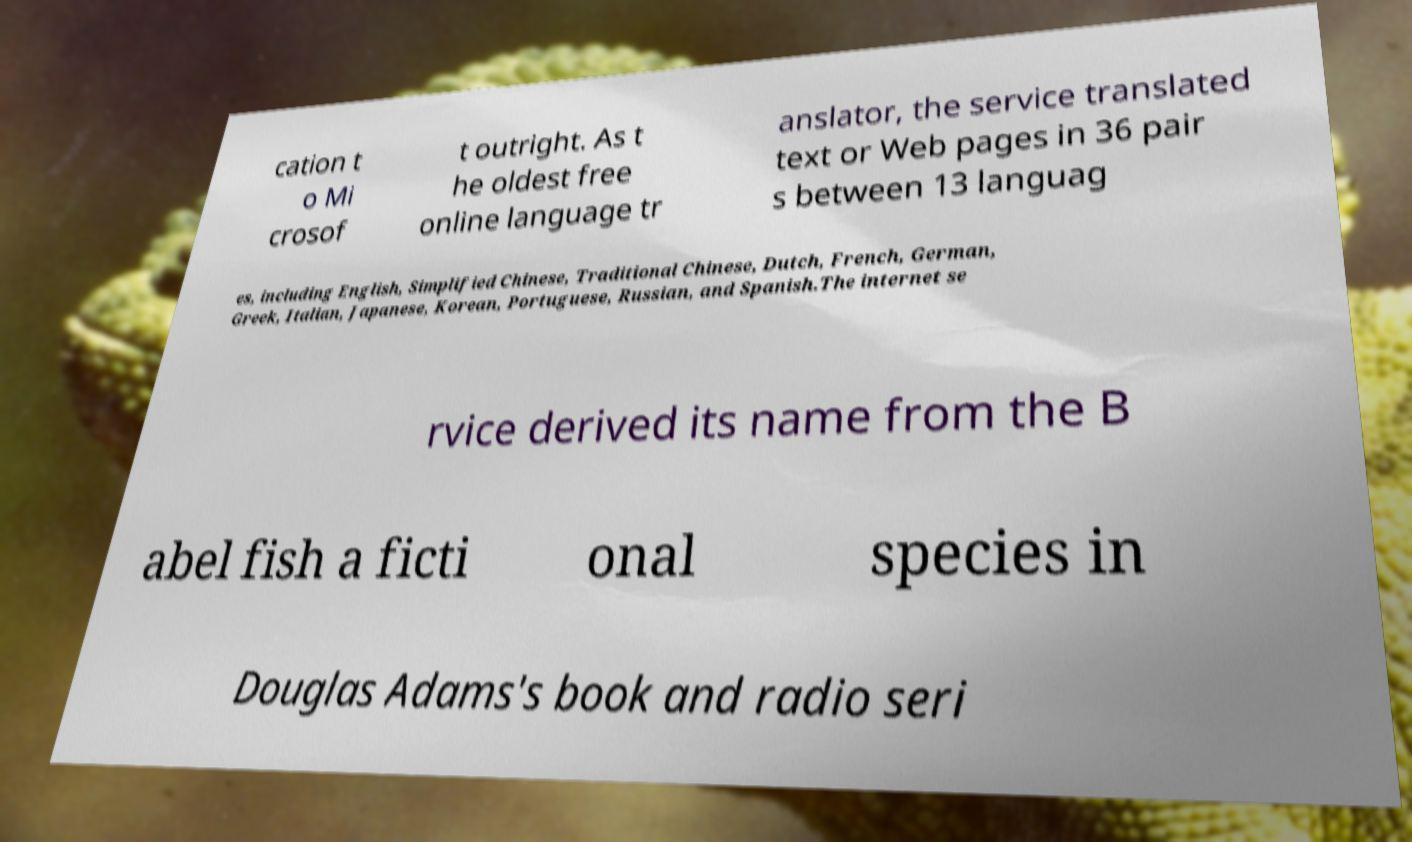Please read and relay the text visible in this image. What does it say? cation t o Mi crosof t outright. As t he oldest free online language tr anslator, the service translated text or Web pages in 36 pair s between 13 languag es, including English, Simplified Chinese, Traditional Chinese, Dutch, French, German, Greek, Italian, Japanese, Korean, Portuguese, Russian, and Spanish.The internet se rvice derived its name from the B abel fish a ficti onal species in Douglas Adams's book and radio seri 